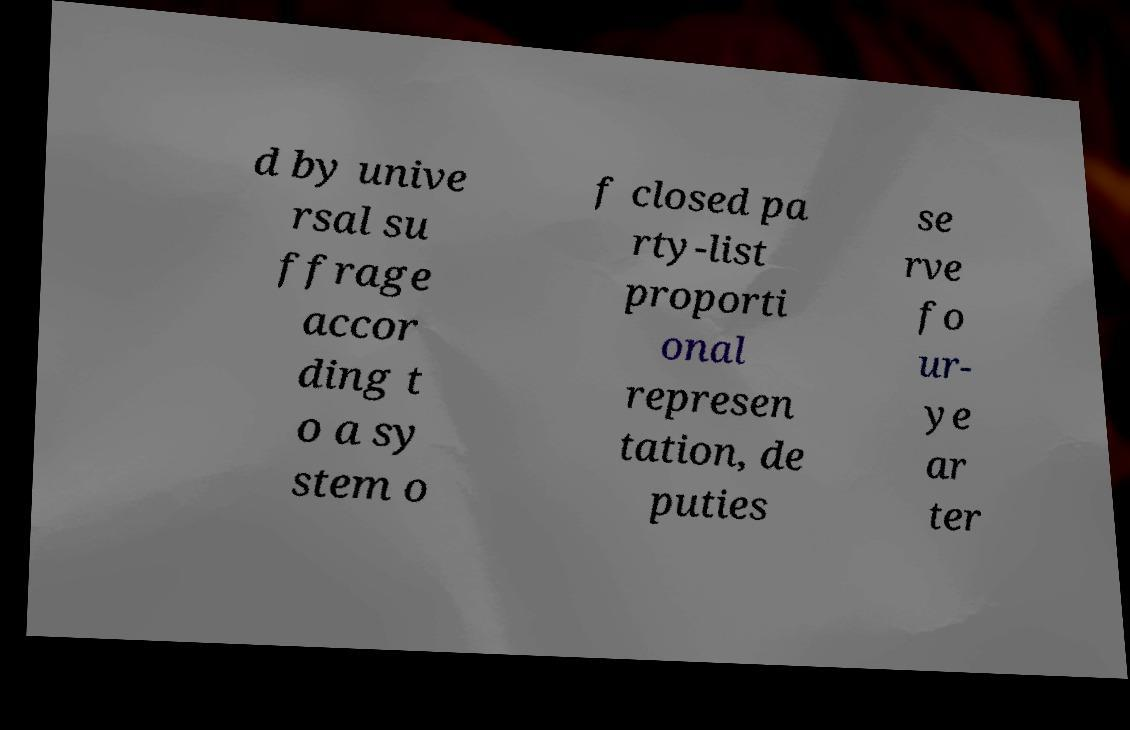Could you assist in decoding the text presented in this image and type it out clearly? d by unive rsal su ffrage accor ding t o a sy stem o f closed pa rty-list proporti onal represen tation, de puties se rve fo ur- ye ar ter 